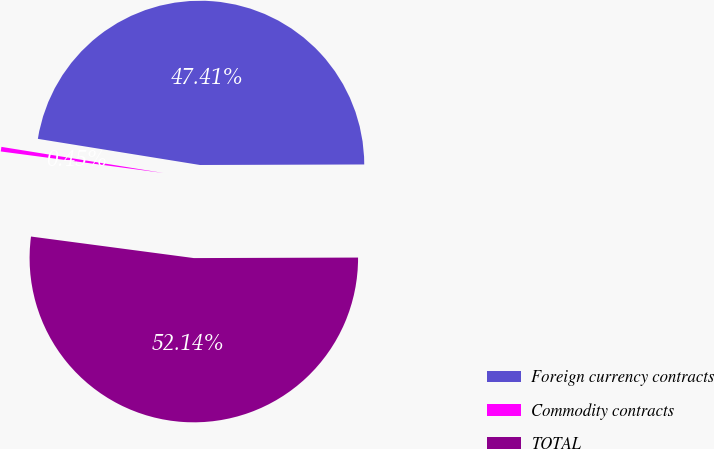<chart> <loc_0><loc_0><loc_500><loc_500><pie_chart><fcel>Foreign currency contracts<fcel>Commodity contracts<fcel>TOTAL<nl><fcel>47.41%<fcel>0.45%<fcel>52.15%<nl></chart> 